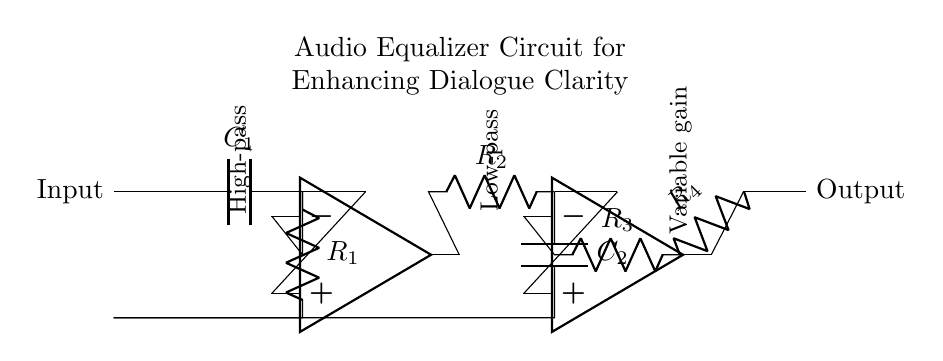What type of circuit is this? This is an audio equalizer circuit designed for enhancing dialogue clarity. The specific arrangement of components shows that it includes a high-pass filter, a low-pass filter, and a variable gain stage.
Answer: Audio equalizer What does capacitor C1 do? Capacitor C1 is part of the high-pass filter, which allows high frequencies to pass while blocking low frequencies, thus helping to clarify the dialogue by reducing background noise.
Answer: Blocks low frequencies What is the function of the buffer in this circuit? The buffer, represented by the operational amplifier, isolates the high-pass filter output from the low-pass filter, preventing loading effects and ensuring that the signal strength is maintained.
Answer: Signal isolation How many resistors are present in the circuit? There are four resistors in the circuit, labelled R1, R2, R3, and R4, arranged in different stages for filtering and amplification purposes.
Answer: Four resistors What is the role of the variable gain stage? The variable gain stage, indicated by the operational amplifier and associated resistors, adjusts the amplitude of the output signal, allowing for dynamic control of dialogue clarity based on audio levels.
Answer: Amplitude adjustment What frequency response does the low-pass filter provide? The low-pass filter allows low frequencies to pass while attenuating higher frequencies, thereby ensuring that the audible dialogue remains clear without unwanted high-frequency noise.
Answer: Attenuates high frequencies 